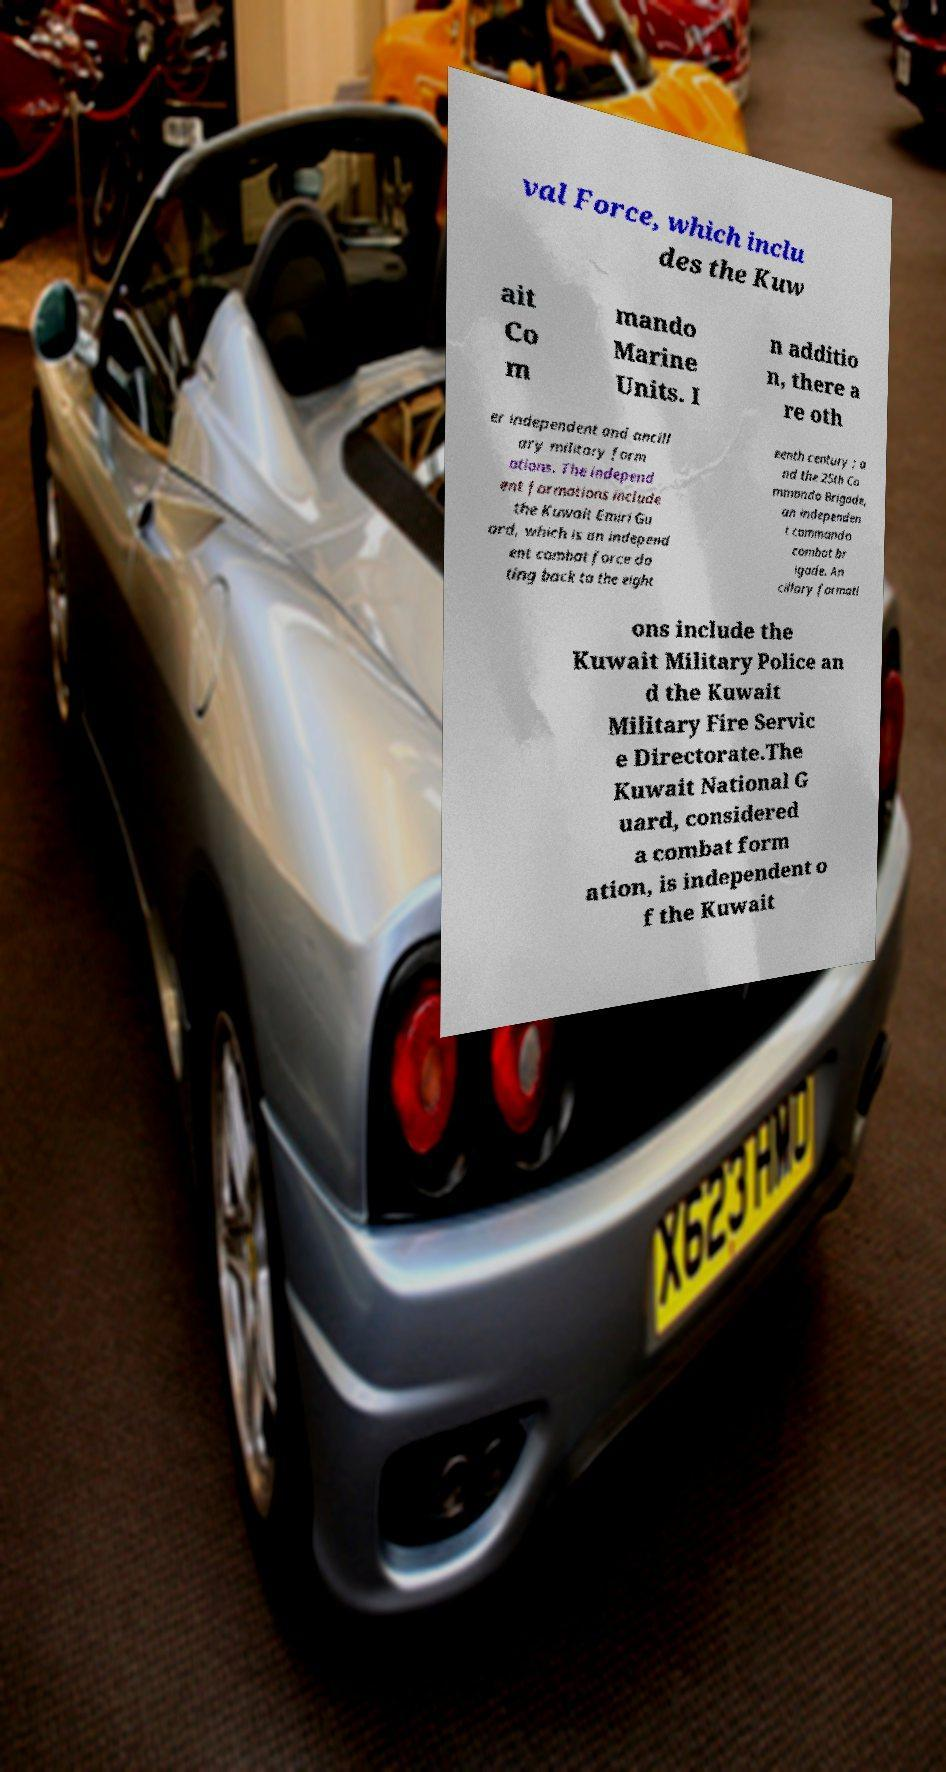Can you read and provide the text displayed in the image?This photo seems to have some interesting text. Can you extract and type it out for me? val Force, which inclu des the Kuw ait Co m mando Marine Units. I n additio n, there a re oth er independent and ancill ary military form ations. The independ ent formations include the Kuwait Emiri Gu ard, which is an independ ent combat force da ting back to the eight eenth century ; a nd the 25th Co mmando Brigade, an independen t commando combat br igade. An cillary formati ons include the Kuwait Military Police an d the Kuwait Military Fire Servic e Directorate.The Kuwait National G uard, considered a combat form ation, is independent o f the Kuwait 